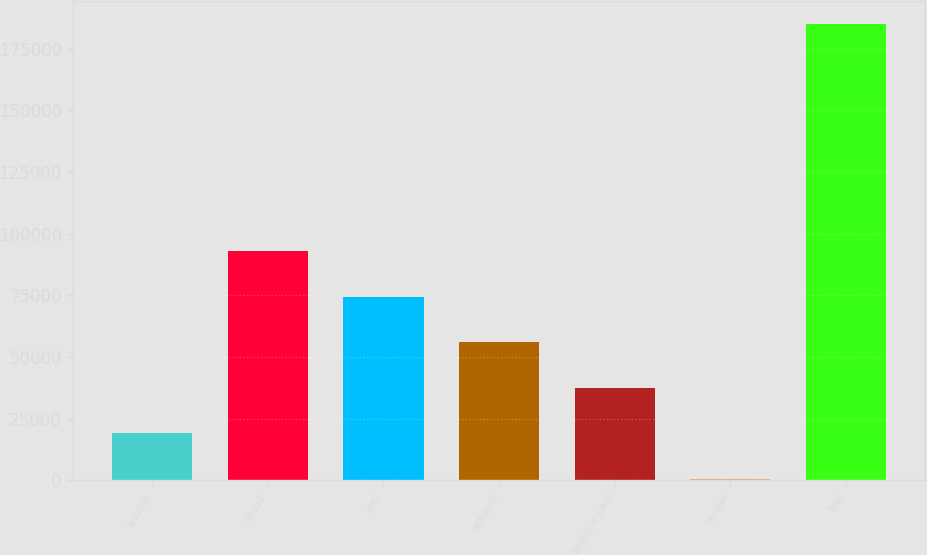Convert chart to OTSL. <chart><loc_0><loc_0><loc_500><loc_500><bar_chart><fcel>AAA/Aaa<fcel>AA/Aa2<fcel>A/A2<fcel>BBB/Baa2<fcel>BB/Ba2 or lower<fcel>Unrated<fcel>Total<nl><fcel>19047.8<fcel>92831<fcel>74385.2<fcel>55939.4<fcel>37493.6<fcel>602<fcel>185060<nl></chart> 